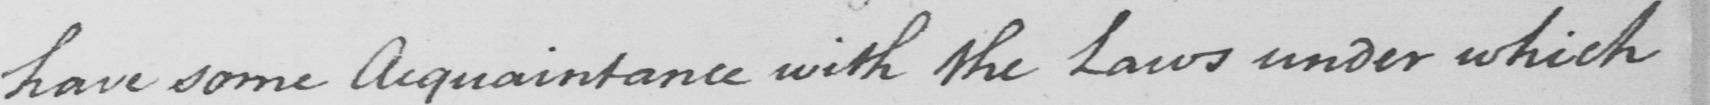Transcribe the text shown in this historical manuscript line. have some Acquaintance with the Laws under which 